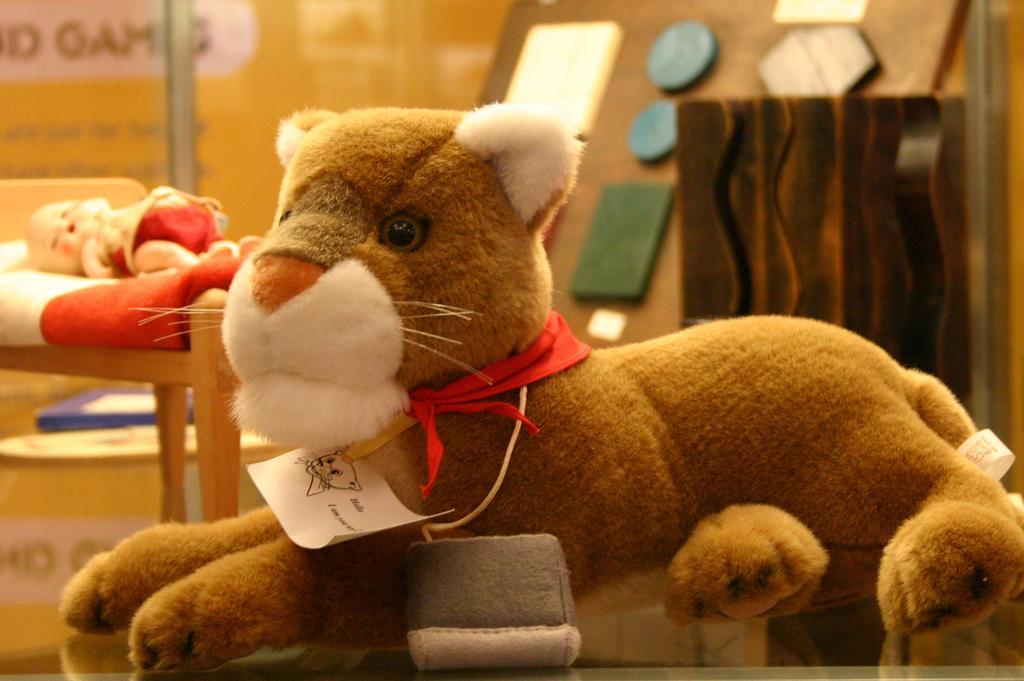Could you give a brief overview of what you see in this image? In this image we can see toys, tag, and few objects. 